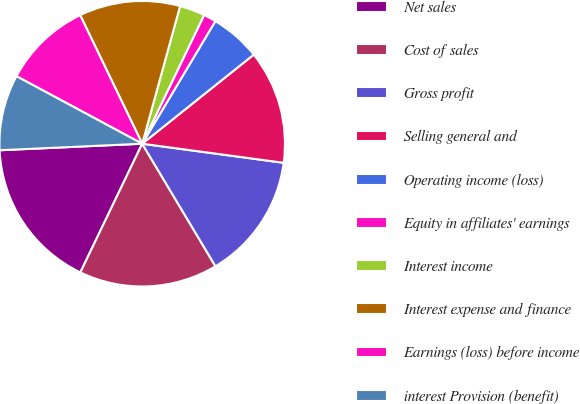Convert chart. <chart><loc_0><loc_0><loc_500><loc_500><pie_chart><fcel>Net sales<fcel>Cost of sales<fcel>Gross profit<fcel>Selling general and<fcel>Operating income (loss)<fcel>Equity in affiliates' earnings<fcel>Interest income<fcel>Interest expense and finance<fcel>Earnings (loss) before income<fcel>interest Provision (benefit)<nl><fcel>17.14%<fcel>15.71%<fcel>14.29%<fcel>12.86%<fcel>5.71%<fcel>1.43%<fcel>2.86%<fcel>11.43%<fcel>10.0%<fcel>8.57%<nl></chart> 